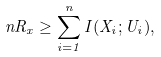<formula> <loc_0><loc_0><loc_500><loc_500>n R _ { x } \geq \sum _ { i = 1 } ^ { n } I ( X _ { i } ; U _ { i } ) ,</formula> 